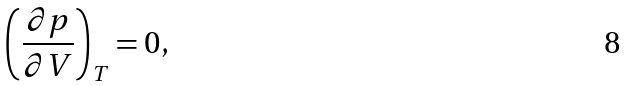<formula> <loc_0><loc_0><loc_500><loc_500>\left ( \frac { \partial p } { \partial V } \right ) _ { T } = 0 ,</formula> 